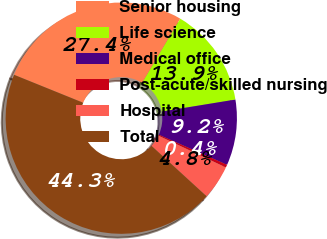Convert chart. <chart><loc_0><loc_0><loc_500><loc_500><pie_chart><fcel>Senior housing<fcel>Life science<fcel>Medical office<fcel>Post-acute/skilled nursing<fcel>Hospital<fcel>Total<nl><fcel>27.4%<fcel>13.91%<fcel>9.18%<fcel>0.4%<fcel>4.79%<fcel>44.32%<nl></chart> 